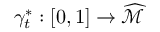<formula> <loc_0><loc_0><loc_500><loc_500>\gamma _ { t } ^ { * } \colon [ 0 , 1 ] \rightarrow \widehat { \mathcal { M } }</formula> 